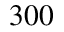Convert formula to latex. <formula><loc_0><loc_0><loc_500><loc_500>3 0 0</formula> 